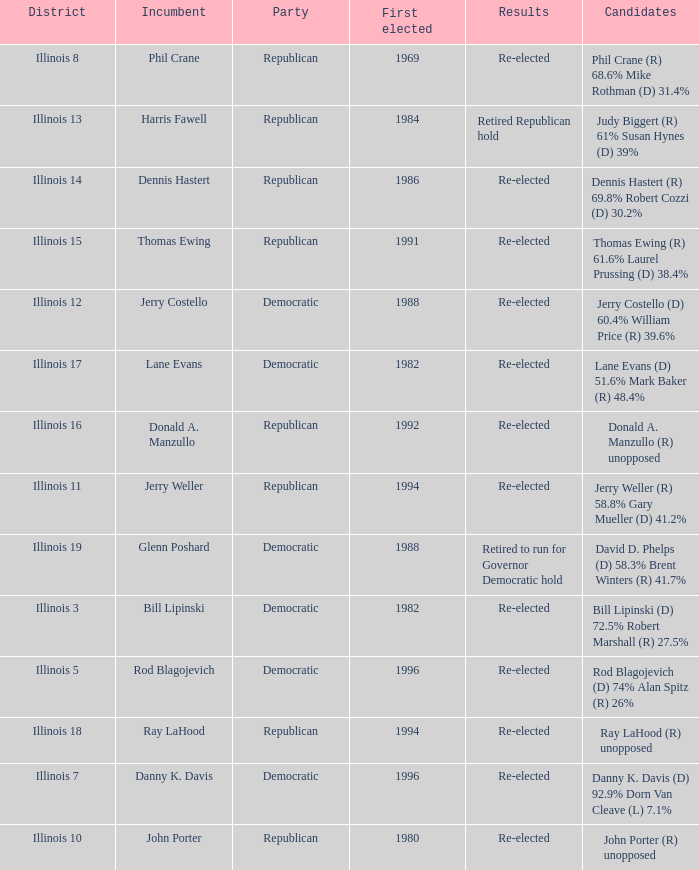Who were the candidates in the district where Jerry Costello won? Jerry Costello (D) 60.4% William Price (R) 39.6%. 